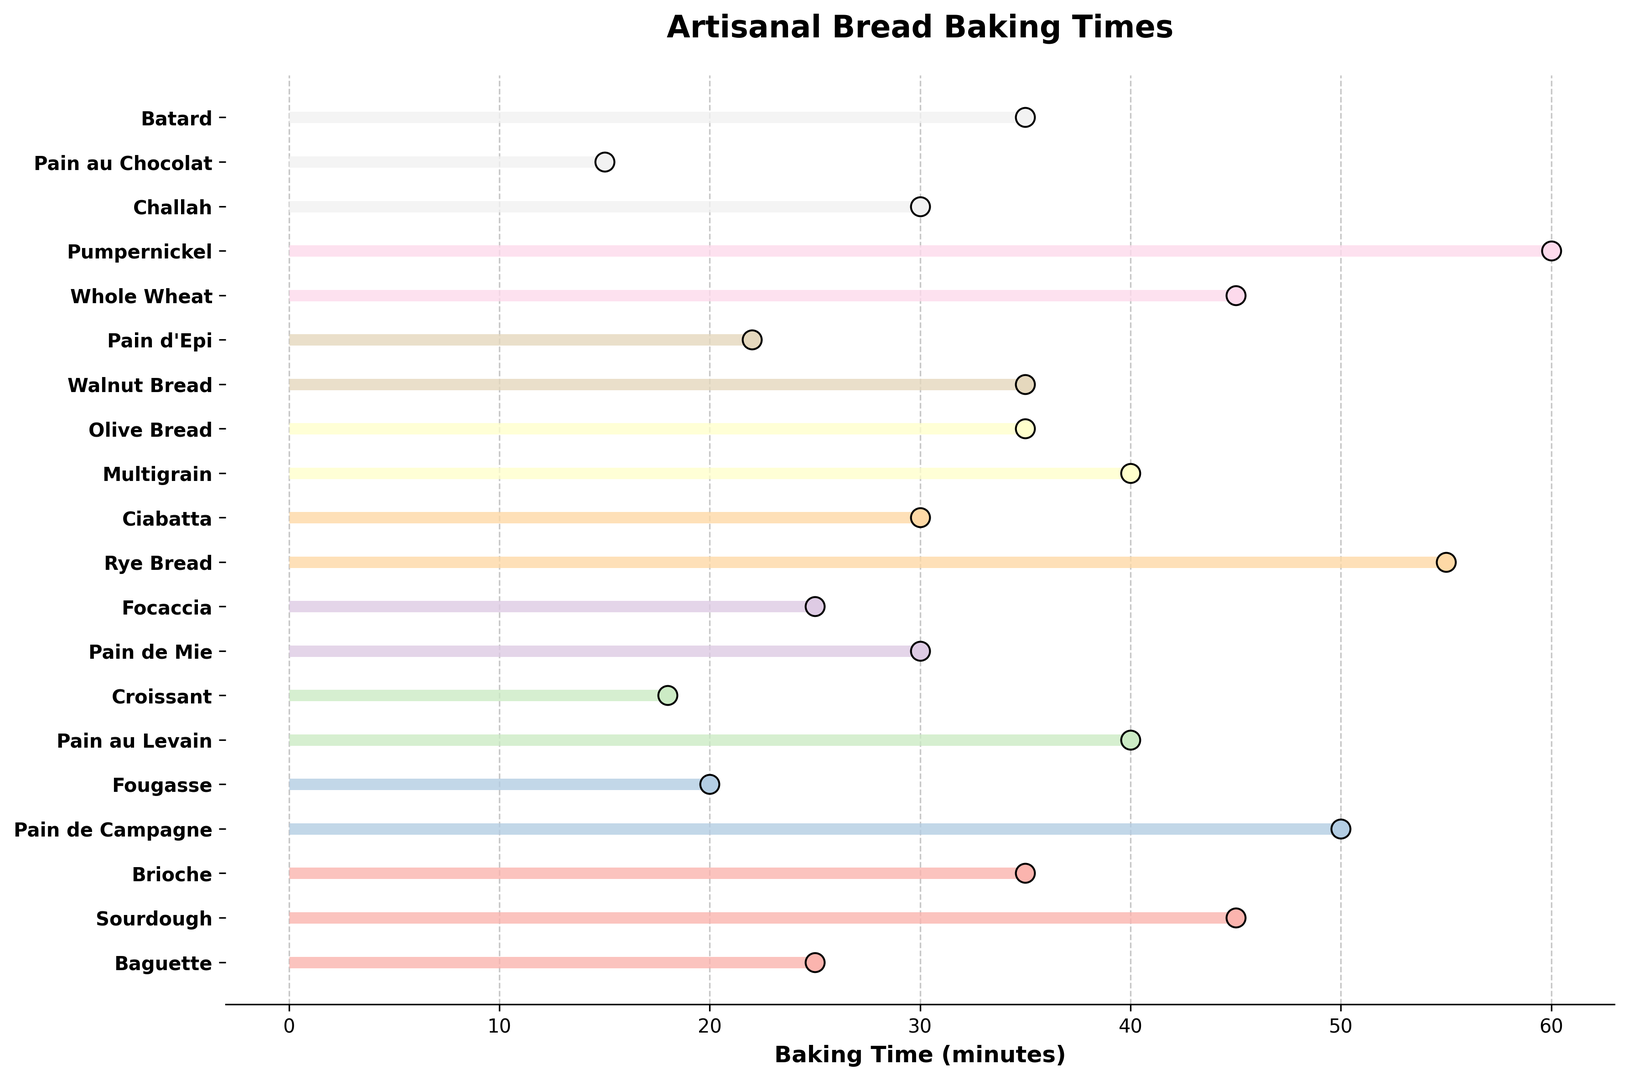What type of bread has the longest baking time? Look at the event plots of each bread type and identify the one with the longest span from StartTime to EndTime. Pumpernickel has the longest baking time which ends at 60 minutes.
Answer: Pumpernickel Which bread type has a baking time of 18 minutes? Identify the event plot that ends exactly at 18 minutes. Croissant is plotted to end at 18 minutes.
Answer: Croissant How many bread types bake longer than 40 minutes? Count the number of bread types where the event line ends after 40 minutes. There are 4 bread types that bake longer than 40 minutes: Sourdough, Pain de Campagne, Rye Bread, and Pumpernickel.
Answer: 4 What is the difference in baking time between Baguette and Fougasse? Find the baking times for Baguette (25 minutes) and Fougasse (20 minutes), then subtract the smaller time from the larger time. The difference is 25 - 20.
Answer: 5 minutes Which bread types bake for exactly 30 minutes? Find the event plots that end exactly at 30 minutes. Three types of bread bake for exactly 30 minutes: Pain de Mie, Ciabatta, and Challah.
Answer: Pain de Mie, Ciabatta, Challah Which bread finishes baking first and how many minutes does it take? Locate the bread type with the earliest EndTime, which is Pain au Chocolat, and check its EndTime. Pain au Chocolat finishes first at 15 minutes.
Answer: Pain au Chocolat, 15 minutes Compare the baking times of Brioche and Batard. Which one bakes longer? Check the event plots of Brioche (35 minutes) and Batard (35 minutes) and compare their EndTimes. Both Brioche and Batard have the same baking time.
Answer: Equal What is the combined baking time of Baguette, Pain de Mie, and Walnut Bread? Add the EndTimes for Baguette (25), Pain de Mie (30), and Walnut Bread (35). The total is 25 + 30 + 35.
Answer: 90 minutes Which bread types finish baking within 25 minutes? Identify bread types with EndTimes of 25 minutes or less. These include Baguette, Fougasse, Croissant, Pain d'Epi, and Pain au Chocolat.
Answer: Baguette, Fougasse, Croissant, Pain d'Epi, Pain au Chocolat How much longer does Pumpernickel bake compared to Multigrain? Determine the difference in EndTimes for Pumpernickel (60) and Multigrain (40). The difference is 60 - 40.
Answer: 20 minutes 